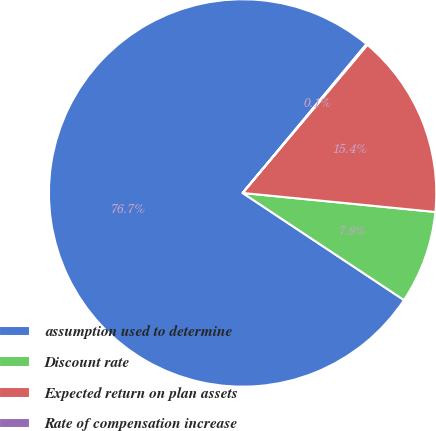Convert chart to OTSL. <chart><loc_0><loc_0><loc_500><loc_500><pie_chart><fcel>assumption used to determine<fcel>Discount rate<fcel>Expected return on plan assets<fcel>Rate of compensation increase<nl><fcel>76.71%<fcel>7.76%<fcel>15.42%<fcel>0.1%<nl></chart> 